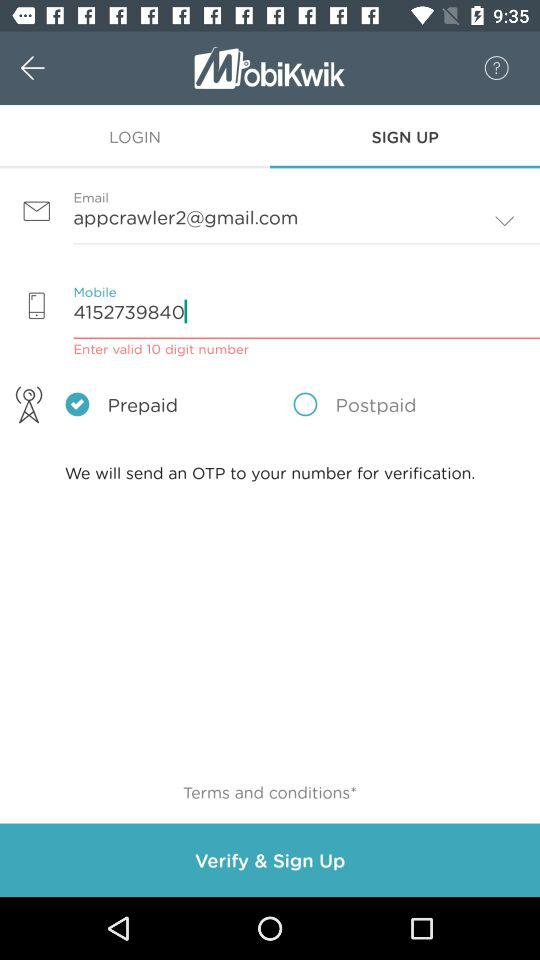Is the number prepaid or postpaid? The number is prepaid. 